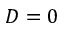Convert formula to latex. <formula><loc_0><loc_0><loc_500><loc_500>D = 0</formula> 